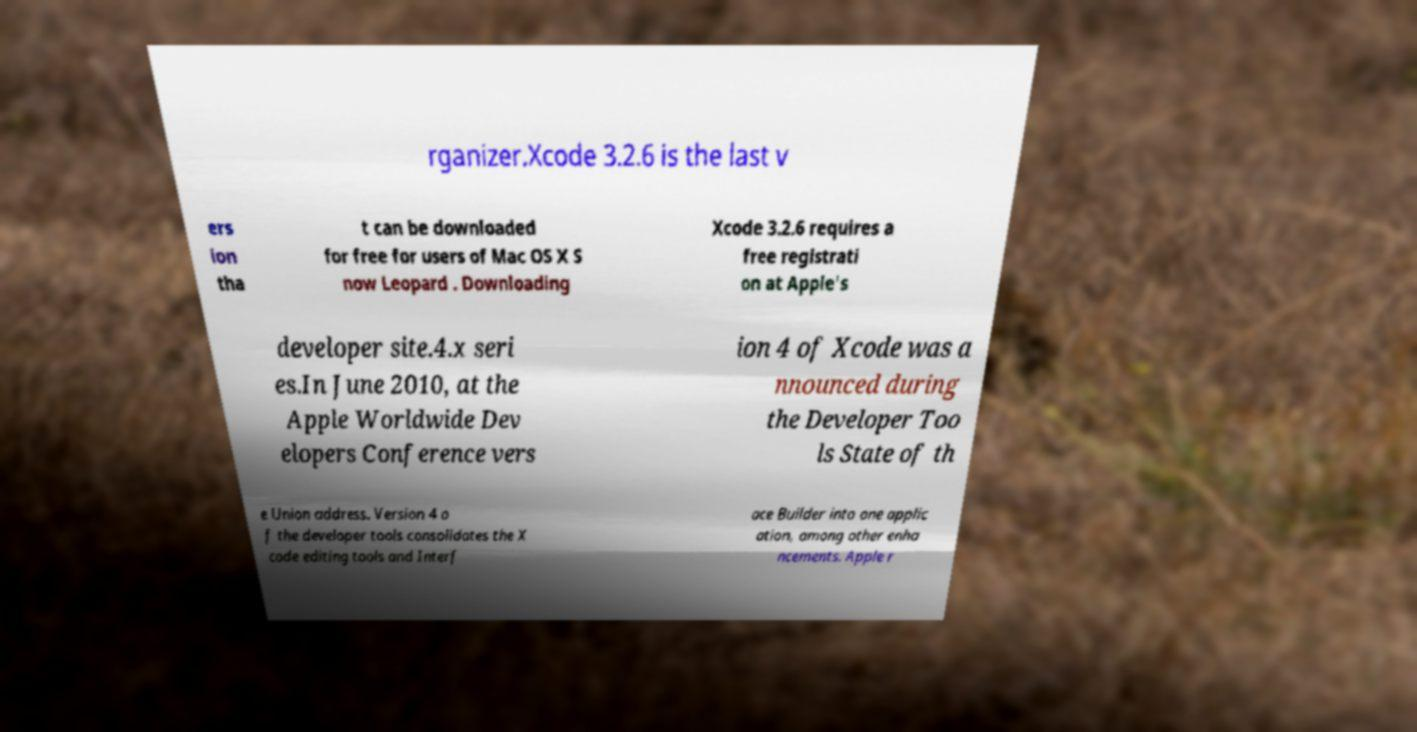What messages or text are displayed in this image? I need them in a readable, typed format. rganizer.Xcode 3.2.6 is the last v ers ion tha t can be downloaded for free for users of Mac OS X S now Leopard . Downloading Xcode 3.2.6 requires a free registrati on at Apple's developer site.4.x seri es.In June 2010, at the Apple Worldwide Dev elopers Conference vers ion 4 of Xcode was a nnounced during the Developer Too ls State of th e Union address. Version 4 o f the developer tools consolidates the X code editing tools and Interf ace Builder into one applic ation, among other enha ncements. Apple r 